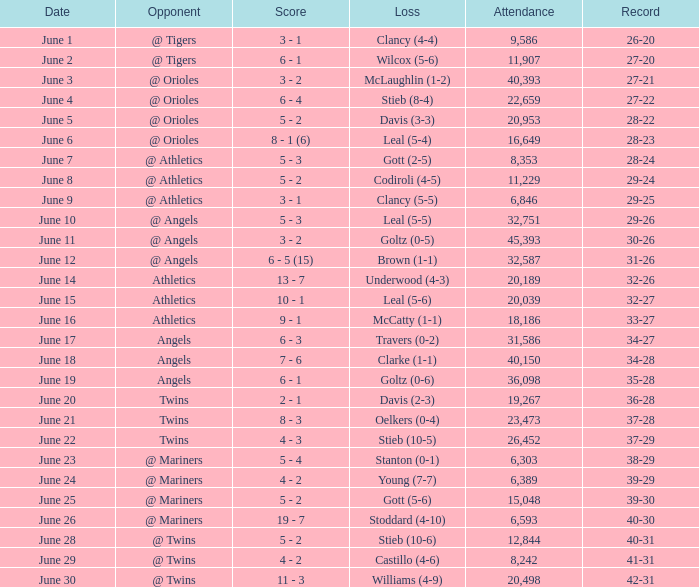What was the record where the opponent was @ Orioles and the loss was to Leal (5-4)? 28-23. 